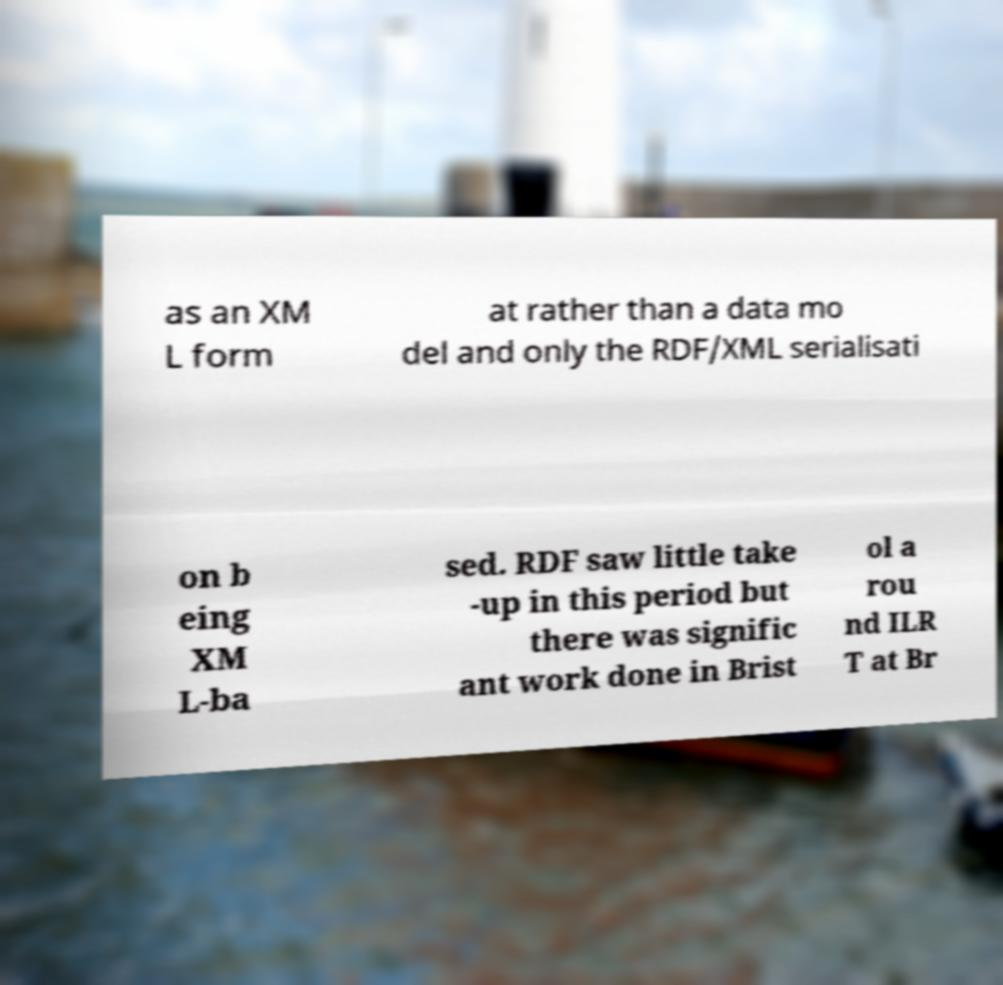Could you extract and type out the text from this image? as an XM L form at rather than a data mo del and only the RDF/XML serialisati on b eing XM L-ba sed. RDF saw little take -up in this period but there was signific ant work done in Brist ol a rou nd ILR T at Br 